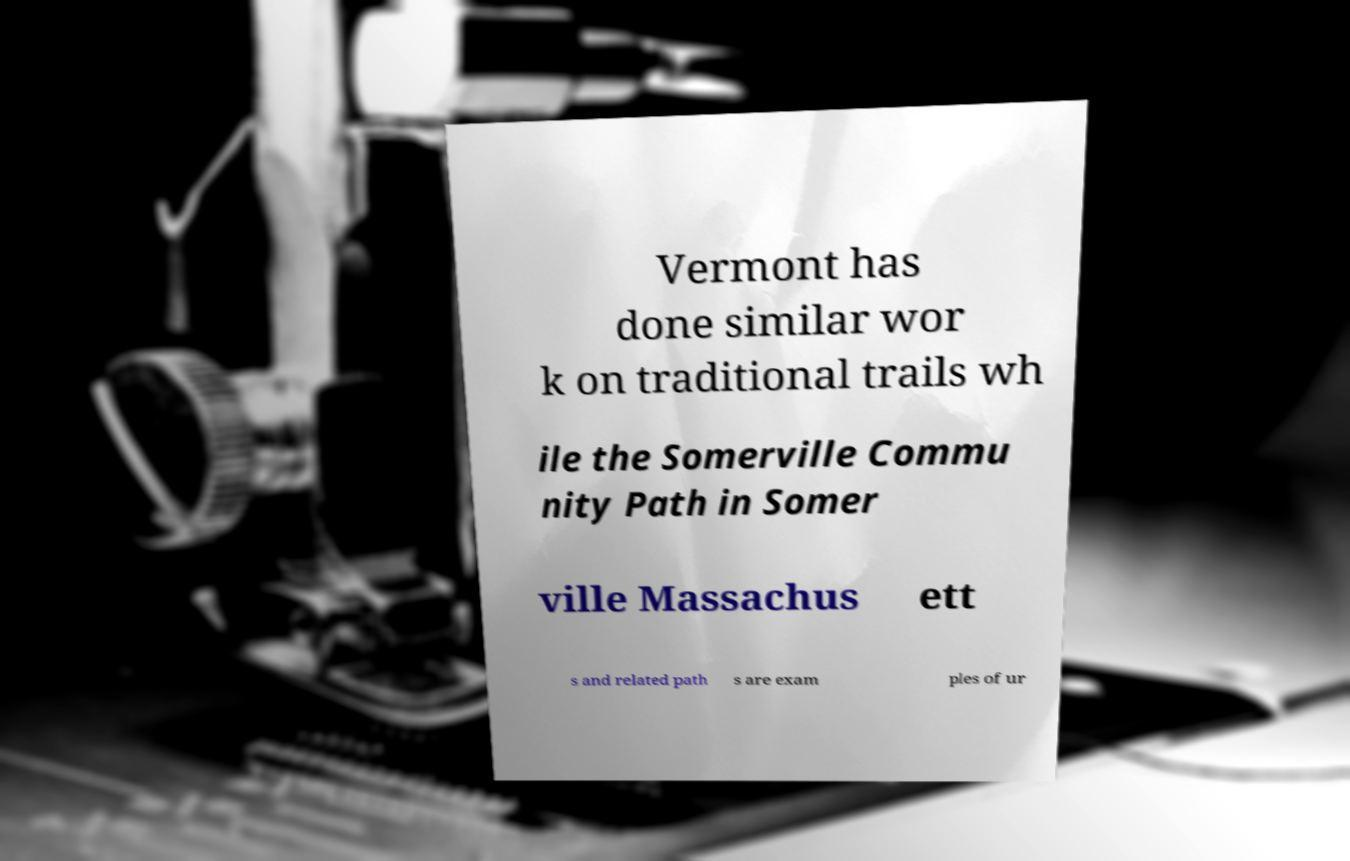Please identify and transcribe the text found in this image. Vermont has done similar wor k on traditional trails wh ile the Somerville Commu nity Path in Somer ville Massachus ett s and related path s are exam ples of ur 